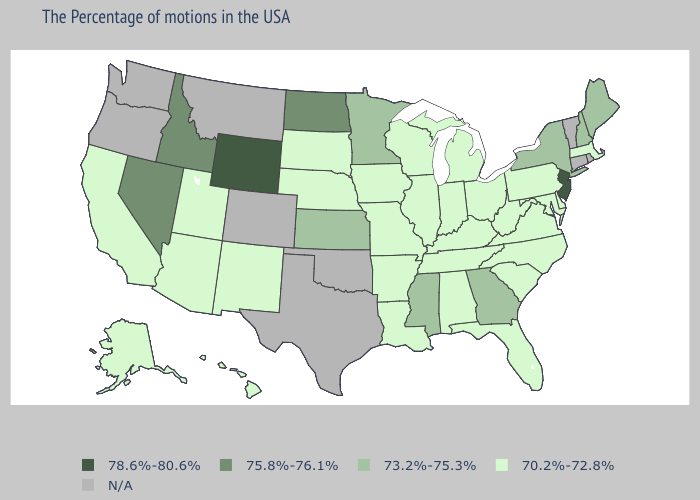Among the states that border Alabama , which have the lowest value?
Keep it brief. Florida, Tennessee. Does Arkansas have the highest value in the South?
Write a very short answer. No. What is the value of Colorado?
Short answer required. N/A. Does Nevada have the lowest value in the USA?
Be succinct. No. Name the states that have a value in the range N/A?
Quick response, please. Rhode Island, Vermont, Connecticut, Oklahoma, Texas, Colorado, Montana, Washington, Oregon. Name the states that have a value in the range 73.2%-75.3%?
Answer briefly. Maine, New Hampshire, New York, Georgia, Mississippi, Minnesota, Kansas. What is the lowest value in the USA?
Be succinct. 70.2%-72.8%. Which states have the highest value in the USA?
Concise answer only. New Jersey, Wyoming. Among the states that border Arizona , which have the highest value?
Give a very brief answer. Nevada. What is the lowest value in states that border Oregon?
Give a very brief answer. 70.2%-72.8%. What is the highest value in the West ?
Give a very brief answer. 78.6%-80.6%. What is the value of South Dakota?
Give a very brief answer. 70.2%-72.8%. What is the highest value in the South ?
Short answer required. 73.2%-75.3%. How many symbols are there in the legend?
Be succinct. 5. Does the first symbol in the legend represent the smallest category?
Short answer required. No. 